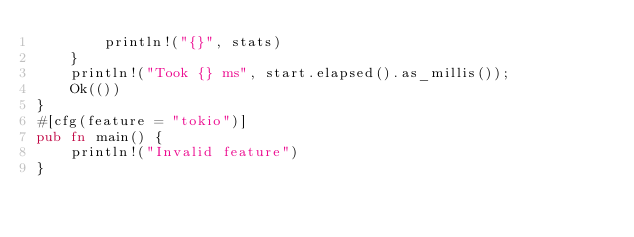<code> <loc_0><loc_0><loc_500><loc_500><_Rust_>        println!("{}", stats)
    }
    println!("Took {} ms", start.elapsed().as_millis());
    Ok(())
}
#[cfg(feature = "tokio")]
pub fn main() {
    println!("Invalid feature")
}
</code> 